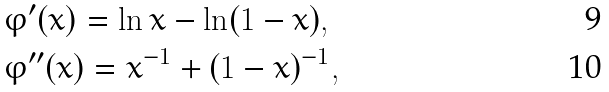<formula> <loc_0><loc_0><loc_500><loc_500>& \varphi ^ { \prime } ( x ) = \ln x - \ln ( 1 - x ) , \\ & \varphi ^ { \prime \prime } ( x ) = x ^ { - 1 } + ( 1 - x ) ^ { - 1 } ,</formula> 